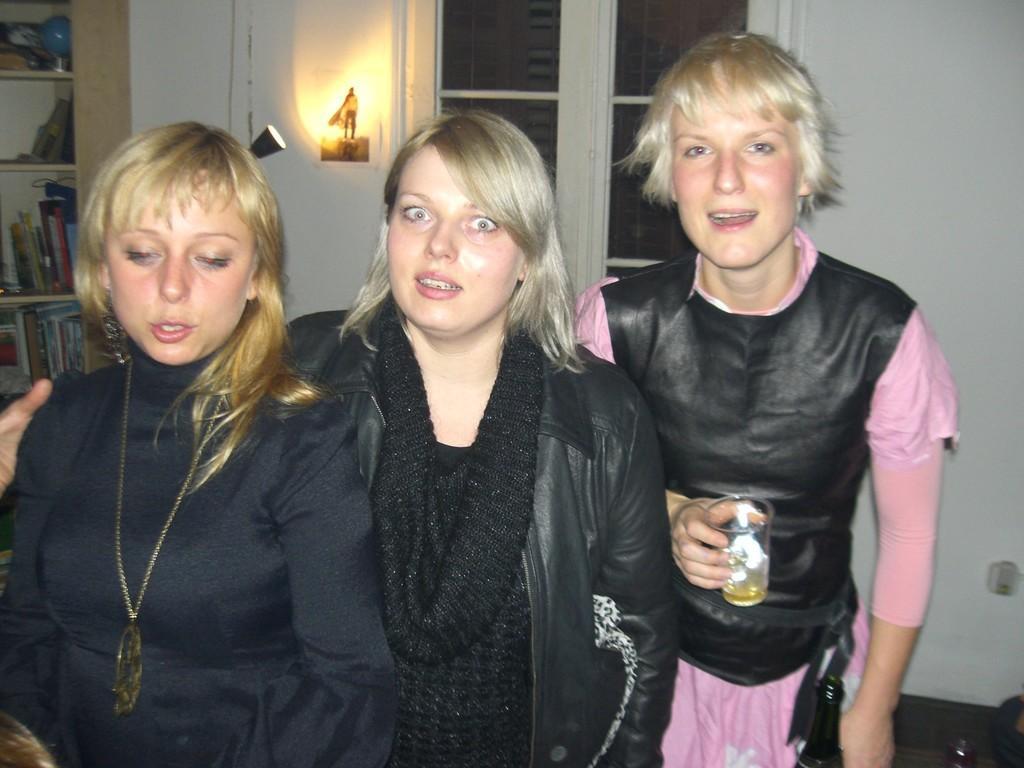How would you summarize this image in a sentence or two? In the picture there are three women, they are giving weird expressions and the third woman is holding a glass. In the background there are some books and other items kept in the shelves and on the rights side there is a window beside the wall. 